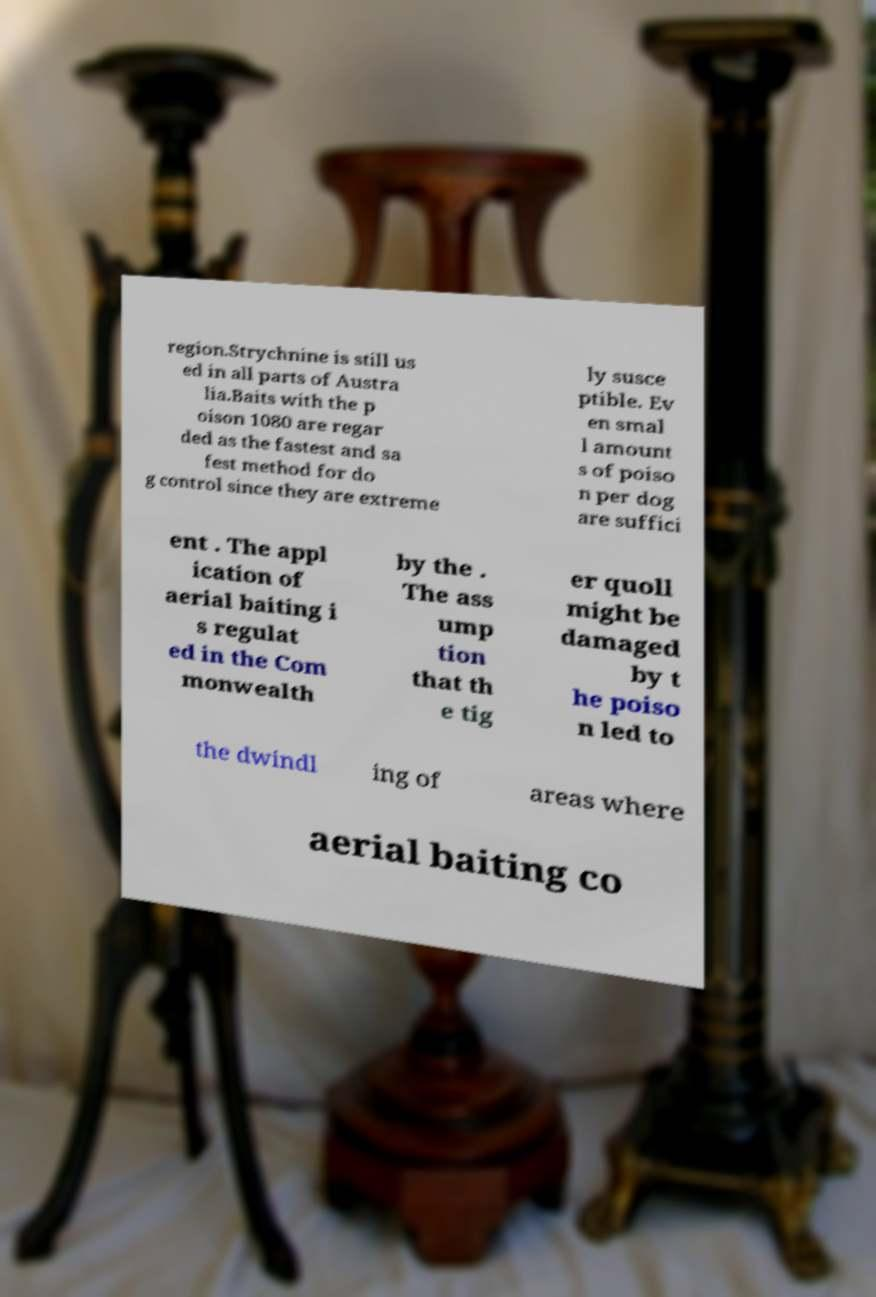Can you accurately transcribe the text from the provided image for me? region.Strychnine is still us ed in all parts of Austra lia.Baits with the p oison 1080 are regar ded as the fastest and sa fest method for do g control since they are extreme ly susce ptible. Ev en smal l amount s of poiso n per dog are suffici ent . The appl ication of aerial baiting i s regulat ed in the Com monwealth by the . The ass ump tion that th e tig er quoll might be damaged by t he poiso n led to the dwindl ing of areas where aerial baiting co 